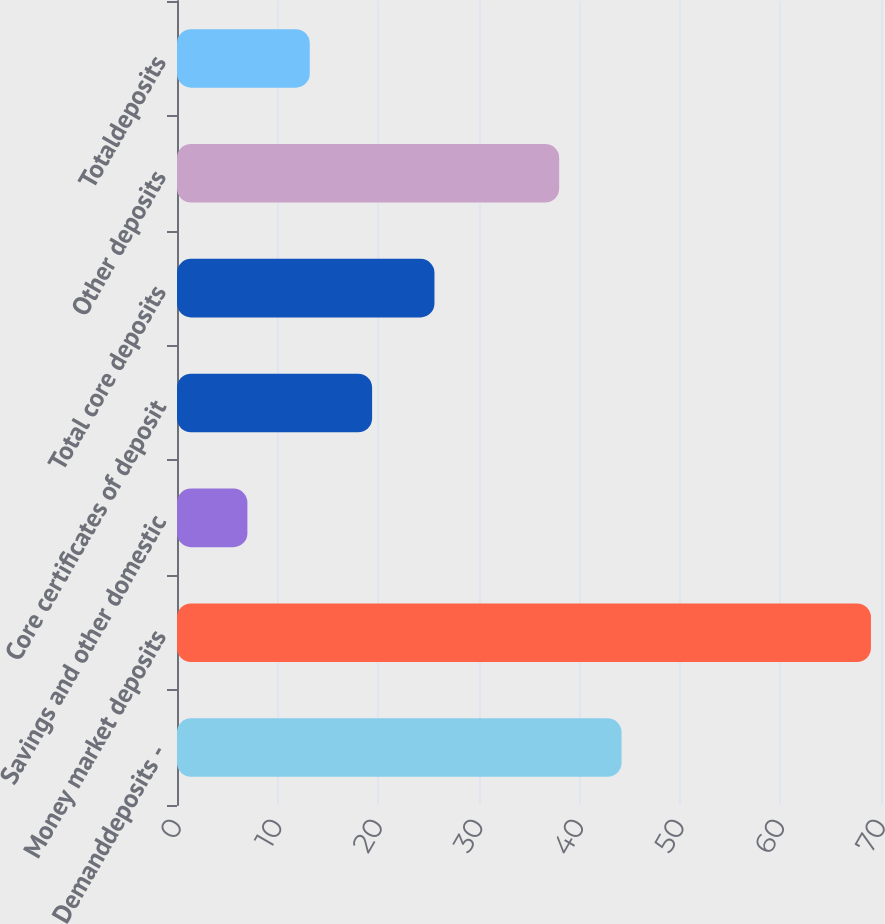Convert chart to OTSL. <chart><loc_0><loc_0><loc_500><loc_500><bar_chart><fcel>Demanddeposits -<fcel>Money market deposits<fcel>Savings and other domestic<fcel>Core certificates of deposit<fcel>Total core deposits<fcel>Other deposits<fcel>Totaldeposits<nl><fcel>44.2<fcel>69<fcel>7<fcel>19.4<fcel>25.6<fcel>38<fcel>13.2<nl></chart> 